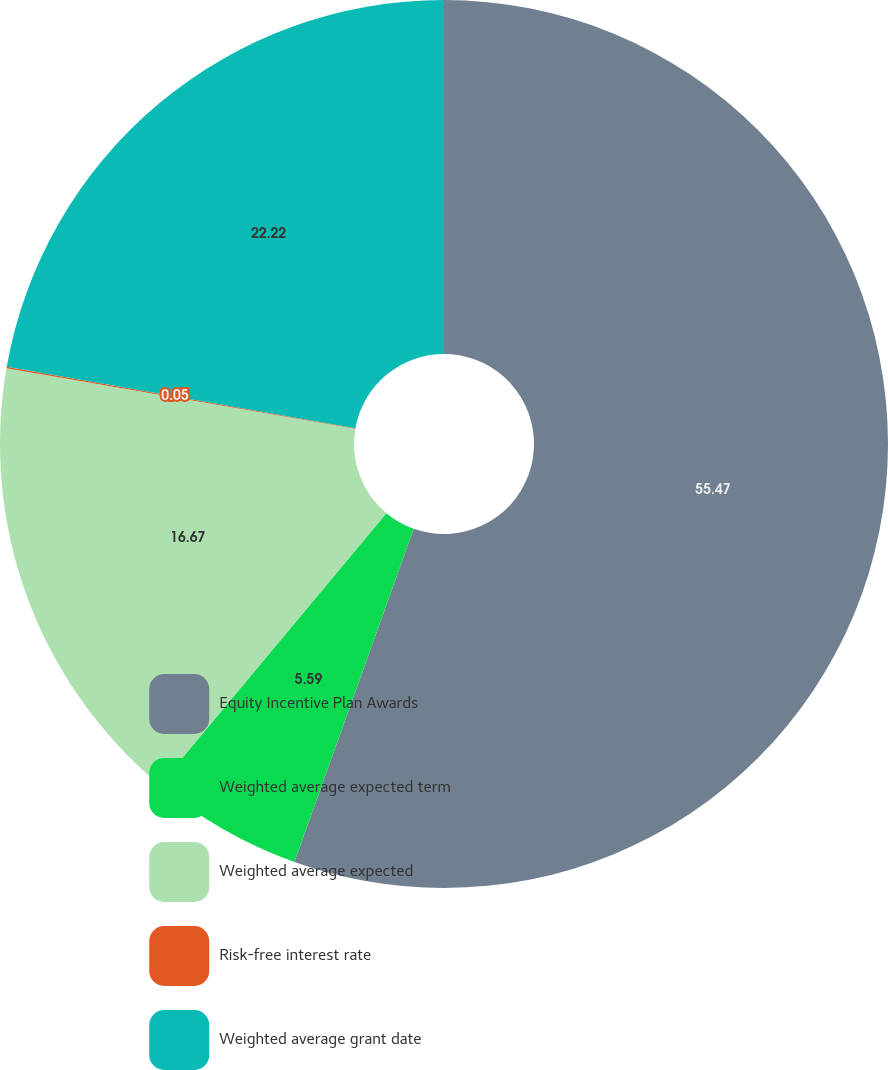Convert chart. <chart><loc_0><loc_0><loc_500><loc_500><pie_chart><fcel>Equity Incentive Plan Awards<fcel>Weighted average expected term<fcel>Weighted average expected<fcel>Risk-free interest rate<fcel>Weighted average grant date<nl><fcel>55.47%<fcel>5.59%<fcel>16.67%<fcel>0.05%<fcel>22.22%<nl></chart> 